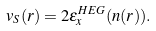Convert formula to latex. <formula><loc_0><loc_0><loc_500><loc_500>v _ { S } ( { r } ) = 2 \epsilon _ { x } ^ { H E G } ( n ( { r } ) ) .</formula> 